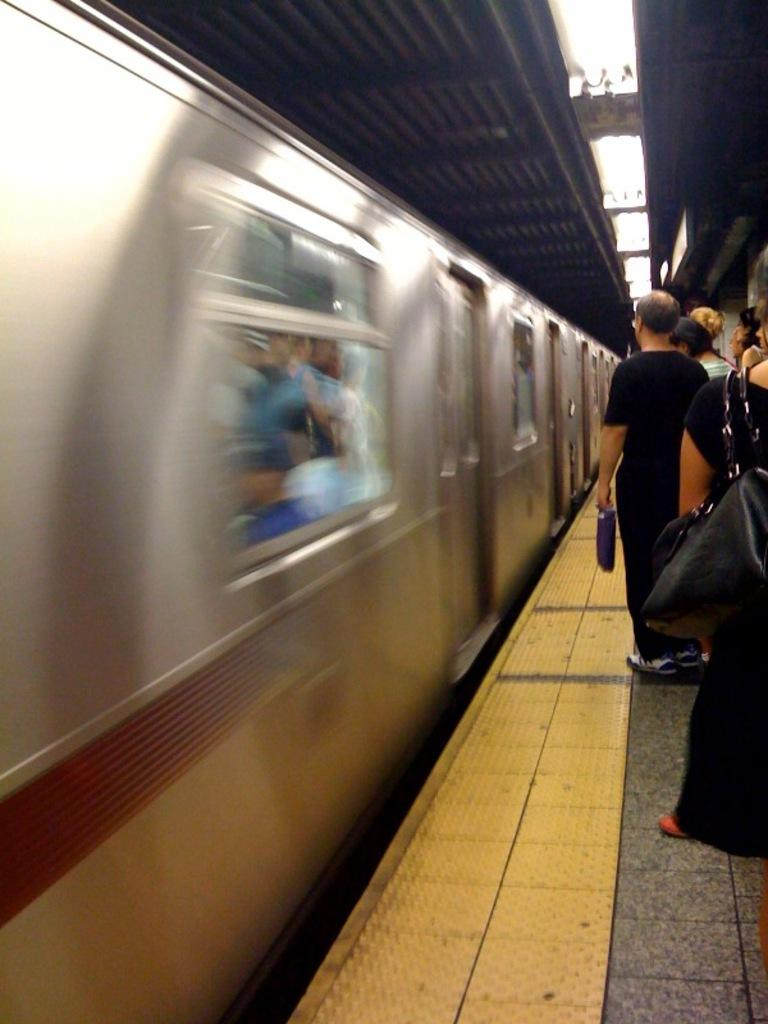What is the main subject of the image? The main subject of the image is a train. Are there any passengers inside the train? Yes, there are people inside the train. What is located beside the train? There is a platform beside the train. Are there any people on the platform? Yes, there are people on the platform. Can you see any jellyfish swimming near the train in the image? No, there are no jellyfish present in the image, as it features a train and a platform. 